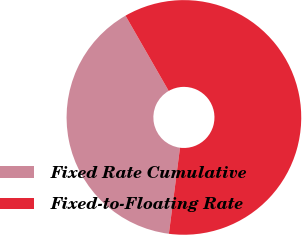Convert chart. <chart><loc_0><loc_0><loc_500><loc_500><pie_chart><fcel>Fixed Rate Cumulative<fcel>Fixed-to-Floating Rate<nl><fcel>39.66%<fcel>60.34%<nl></chart> 